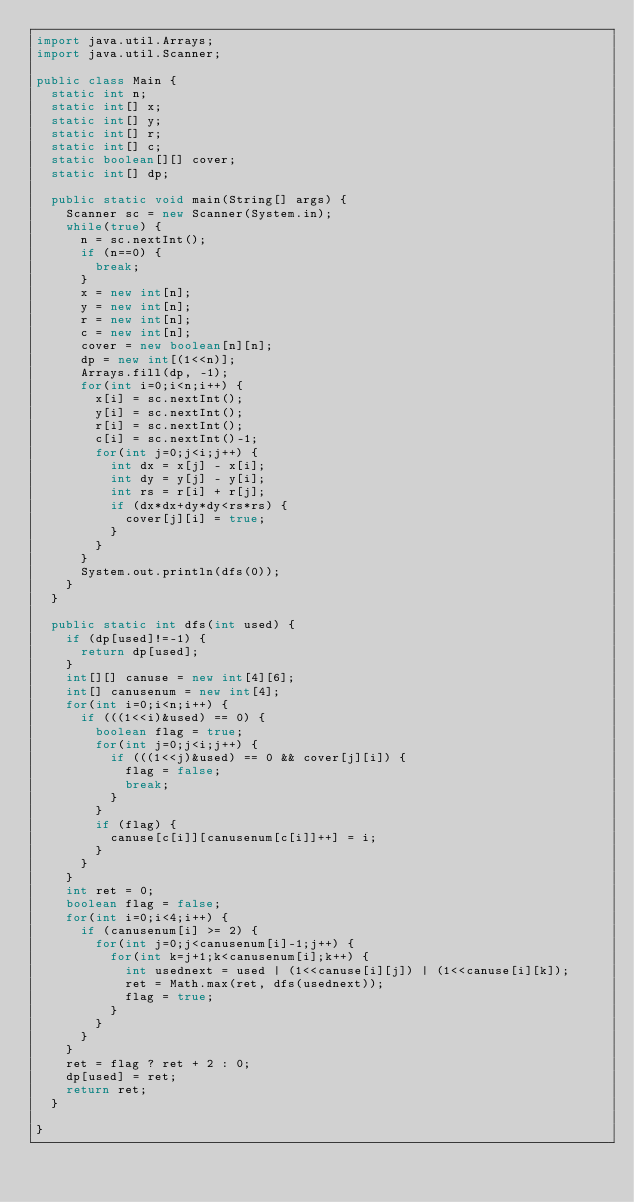Convert code to text. <code><loc_0><loc_0><loc_500><loc_500><_Java_>import java.util.Arrays;
import java.util.Scanner;

public class Main {
	static int n;
	static int[] x;
	static int[] y;
	static int[] r;
	static int[] c;
	static boolean[][] cover;
	static int[] dp;

	public static void main(String[] args) {
		Scanner sc = new Scanner(System.in);
		while(true) {
			n = sc.nextInt();
			if (n==0) {
				break;
			}
			x = new int[n];
			y = new int[n];
			r = new int[n];
			c = new int[n];
			cover = new boolean[n][n];
			dp = new int[(1<<n)];
			Arrays.fill(dp, -1);
			for(int i=0;i<n;i++) {
				x[i] = sc.nextInt();
				y[i] = sc.nextInt();
				r[i] = sc.nextInt();
				c[i] = sc.nextInt()-1;
				for(int j=0;j<i;j++) {
					int dx = x[j] - x[i];
					int dy = y[j] - y[i];
					int rs = r[i] + r[j];
					if (dx*dx+dy*dy<rs*rs) {
						cover[j][i] = true;
					}
				}
			}
			System.out.println(dfs(0));
		}
	}

	public static int dfs(int used) {
		if (dp[used]!=-1) {
			return dp[used];
		}
		int[][] canuse = new int[4][6];
		int[] canusenum = new int[4];
		for(int i=0;i<n;i++) {
			if (((1<<i)&used) == 0) {
				boolean flag = true;
				for(int j=0;j<i;j++) {
					if (((1<<j)&used) == 0 && cover[j][i]) {
						flag = false;
						break;
					}
				}
				if (flag) {
					canuse[c[i]][canusenum[c[i]]++] = i;
				}
			}
		}
		int ret = 0;
		boolean flag = false;
		for(int i=0;i<4;i++) {
			if (canusenum[i] >= 2) {
				for(int j=0;j<canusenum[i]-1;j++) {
					for(int k=j+1;k<canusenum[i];k++) {
						int usednext = used | (1<<canuse[i][j]) | (1<<canuse[i][k]);
						ret = Math.max(ret, dfs(usednext));
						flag = true;
					}
				}
			}
		}
		ret = flag ? ret + 2 : 0;
		dp[used] = ret;
		return ret;
	}

}</code> 